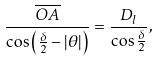Convert formula to latex. <formula><loc_0><loc_0><loc_500><loc_500>\frac { \overline { O A } } { \cos \left ( \frac { \delta } { 2 } - \left | \theta \right | \right ) } = \frac { D _ { l } } { \cos \frac { \delta } { 2 } } ,</formula> 